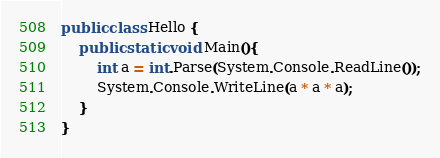<code> <loc_0><loc_0><loc_500><loc_500><_C#_>public class Hello {
    public static void Main(){
        int a = int.Parse(System.Console.ReadLine());
        System.Console.WriteLine(a * a * a);
    }
}

</code> 